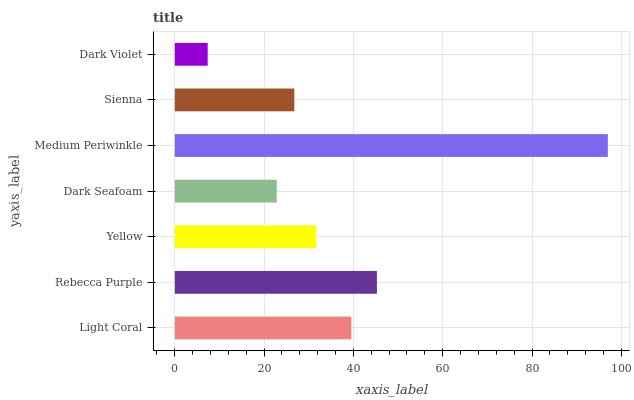Is Dark Violet the minimum?
Answer yes or no. Yes. Is Medium Periwinkle the maximum?
Answer yes or no. Yes. Is Rebecca Purple the minimum?
Answer yes or no. No. Is Rebecca Purple the maximum?
Answer yes or no. No. Is Rebecca Purple greater than Light Coral?
Answer yes or no. Yes. Is Light Coral less than Rebecca Purple?
Answer yes or no. Yes. Is Light Coral greater than Rebecca Purple?
Answer yes or no. No. Is Rebecca Purple less than Light Coral?
Answer yes or no. No. Is Yellow the high median?
Answer yes or no. Yes. Is Yellow the low median?
Answer yes or no. Yes. Is Sienna the high median?
Answer yes or no. No. Is Dark Violet the low median?
Answer yes or no. No. 